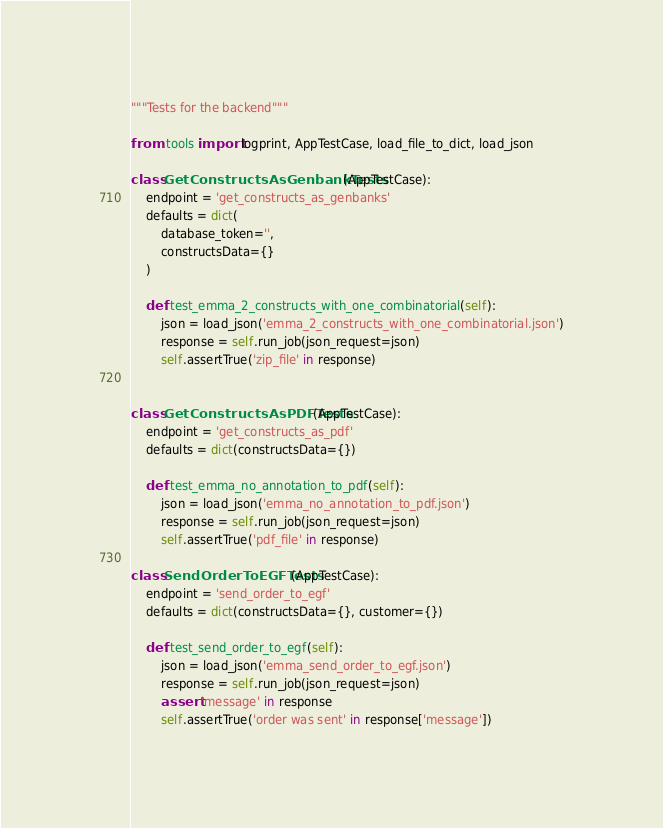<code> <loc_0><loc_0><loc_500><loc_500><_Python_>"""Tests for the backend"""

from .tools import logprint, AppTestCase, load_file_to_dict, load_json

class GetConstructsAsGenbankTests(AppTestCase):
    endpoint = 'get_constructs_as_genbanks'
    defaults = dict(
        database_token='',
        constructsData={}
    )

    def test_emma_2_constructs_with_one_combinatorial(self):
        json = load_json('emma_2_constructs_with_one_combinatorial.json')
        response = self.run_job(json_request=json)
        self.assertTrue('zip_file' in response)


class GetConstructsAsPDFTests(AppTestCase):
    endpoint = 'get_constructs_as_pdf'
    defaults = dict(constructsData={})

    def test_emma_no_annotation_to_pdf(self):
        json = load_json('emma_no_annotation_to_pdf.json')
        response = self.run_job(json_request=json)
        self.assertTrue('pdf_file' in response)

class SendOrderToEGFTests(AppTestCase):
    endpoint = 'send_order_to_egf'
    defaults = dict(constructsData={}, customer={})

    def test_send_order_to_egf(self):
        json = load_json('emma_send_order_to_egf.json')
        response = self.run_job(json_request=json)
        assert 'message' in response
        self.assertTrue('order was sent' in response['message'])
</code> 